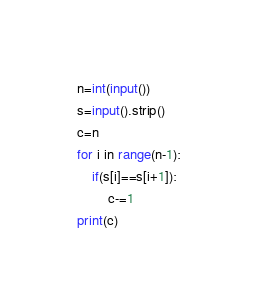Convert code to text. <code><loc_0><loc_0><loc_500><loc_500><_Python_>n=int(input())
s=input().strip()
c=n
for i in range(n-1):
    if(s[i]==s[i+1]):
        c-=1
print(c)
</code> 